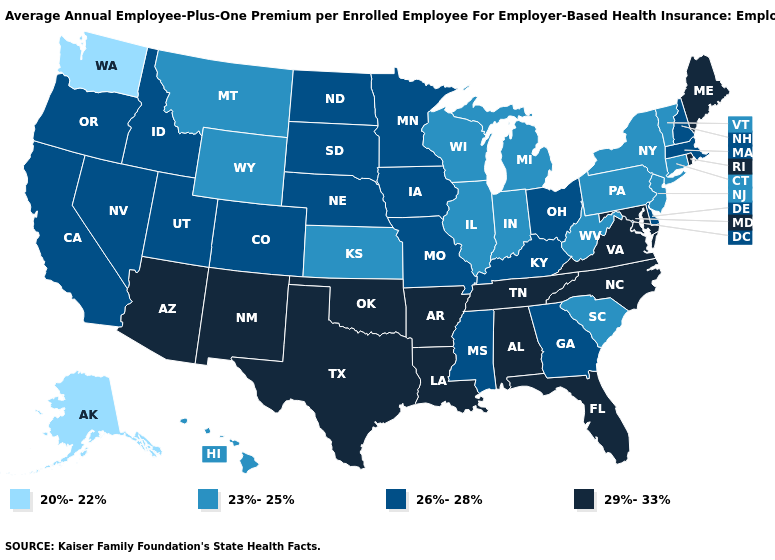Which states have the lowest value in the West?
Write a very short answer. Alaska, Washington. Does Maine have the same value as Utah?
Write a very short answer. No. What is the value of Arkansas?
Give a very brief answer. 29%-33%. Name the states that have a value in the range 29%-33%?
Keep it brief. Alabama, Arizona, Arkansas, Florida, Louisiana, Maine, Maryland, New Mexico, North Carolina, Oklahoma, Rhode Island, Tennessee, Texas, Virginia. Among the states that border West Virginia , does Pennsylvania have the lowest value?
Short answer required. Yes. What is the lowest value in the USA?
Give a very brief answer. 20%-22%. What is the lowest value in the Northeast?
Give a very brief answer. 23%-25%. What is the lowest value in the South?
Be succinct. 23%-25%. Which states have the highest value in the USA?
Write a very short answer. Alabama, Arizona, Arkansas, Florida, Louisiana, Maine, Maryland, New Mexico, North Carolina, Oklahoma, Rhode Island, Tennessee, Texas, Virginia. What is the value of Iowa?
Answer briefly. 26%-28%. What is the value of Kentucky?
Short answer required. 26%-28%. What is the highest value in states that border Maryland?
Be succinct. 29%-33%. What is the highest value in the USA?
Answer briefly. 29%-33%. What is the lowest value in the South?
Concise answer only. 23%-25%. 